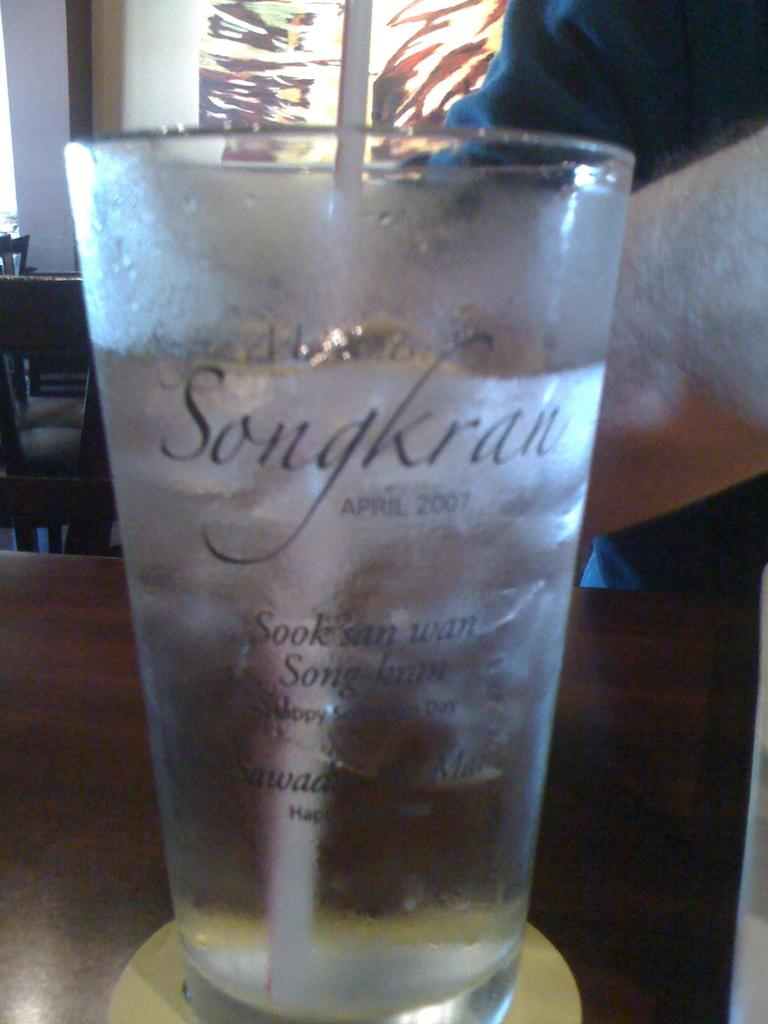Provide a one-sentence caption for the provided image. A cold frosted glass is labeled with the name Songkran. 